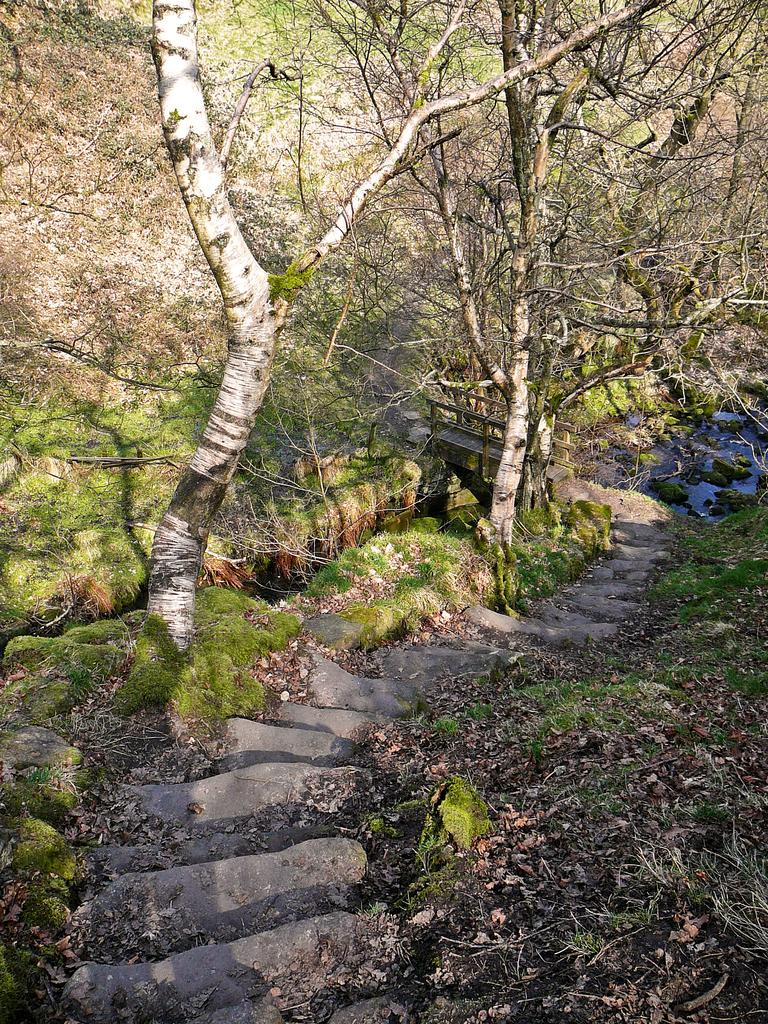What type of vegetation is present in the image? There is grass and trees in the image. Can you describe the natural environment depicted in the image? The image features grass, trees, and water visible in the background. What type of lunch is being served in the image? There is no lunch present in the image; it features grass, trees, and water in a natural environment. 